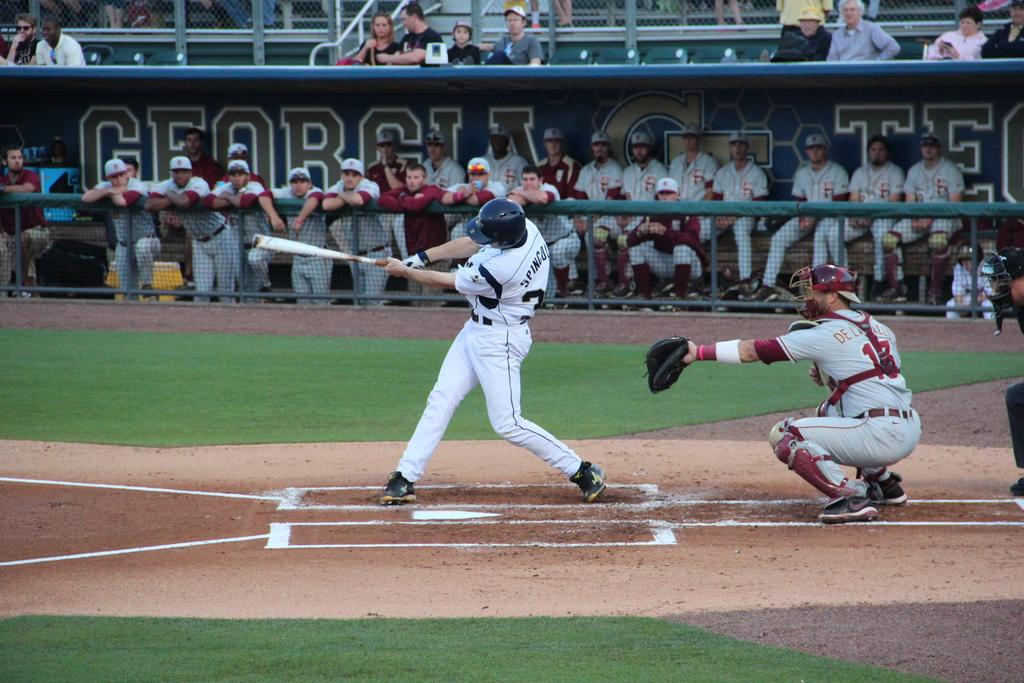<image>
Offer a succinct explanation of the picture presented. Baseball batter playing for team Georgia swinging to hit the ball. 